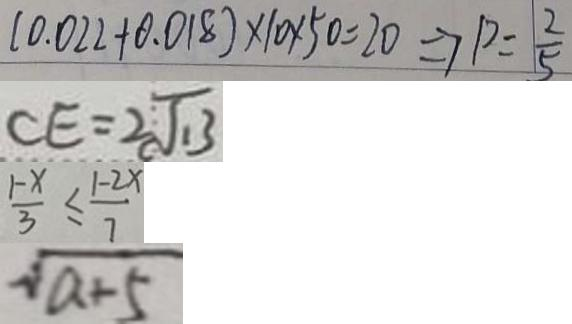Convert formula to latex. <formula><loc_0><loc_0><loc_500><loc_500>( 0 . 0 2 2 + 0 . 0 1 8 ) \times 1 0 \times 5 0 = 2 0 \Rightarrow p = \frac { 2 } { 5 } 
 C E = 2 \sqrt { 1 3 } 
 \frac { 1 - x } { 3 } \leq \frac { 1 - 2 x } { 7 } 
 \sqrt { a + 5 }</formula> 